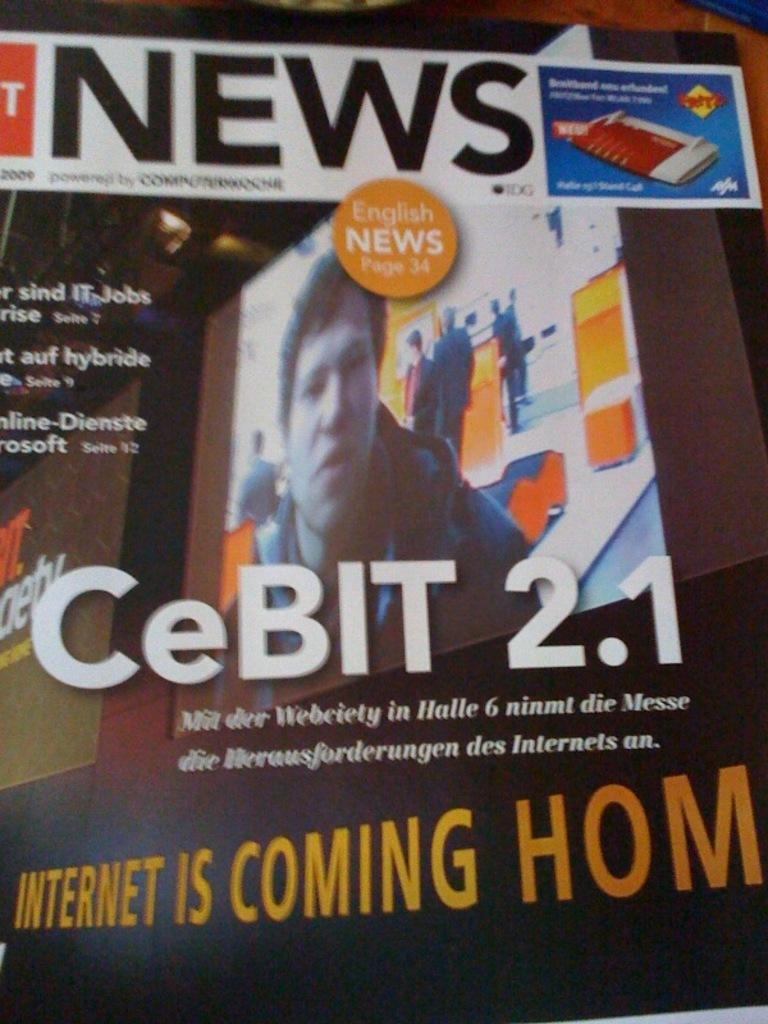<image>
Write a terse but informative summary of the picture. A poster stating CeBIT 2.1 and English News 